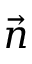Convert formula to latex. <formula><loc_0><loc_0><loc_500><loc_500>\vec { n }</formula> 